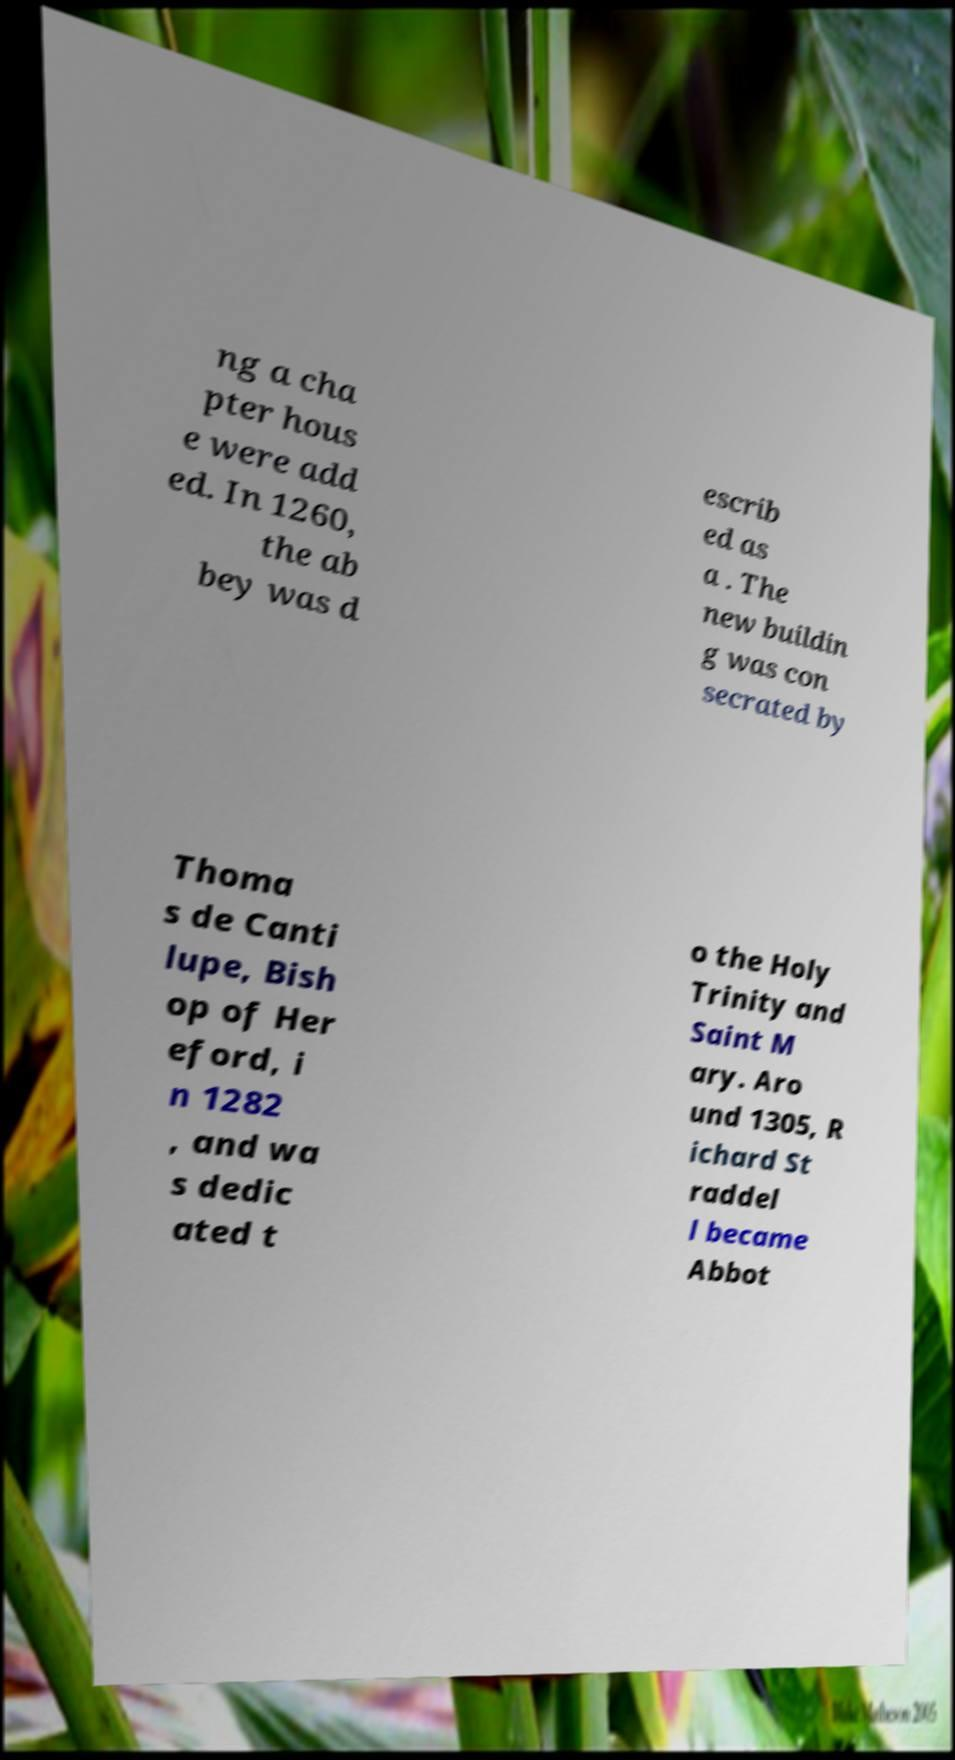What messages or text are displayed in this image? I need them in a readable, typed format. ng a cha pter hous e were add ed. In 1260, the ab bey was d escrib ed as a . The new buildin g was con secrated by Thoma s de Canti lupe, Bish op of Her eford, i n 1282 , and wa s dedic ated t o the Holy Trinity and Saint M ary. Aro und 1305, R ichard St raddel l became Abbot 